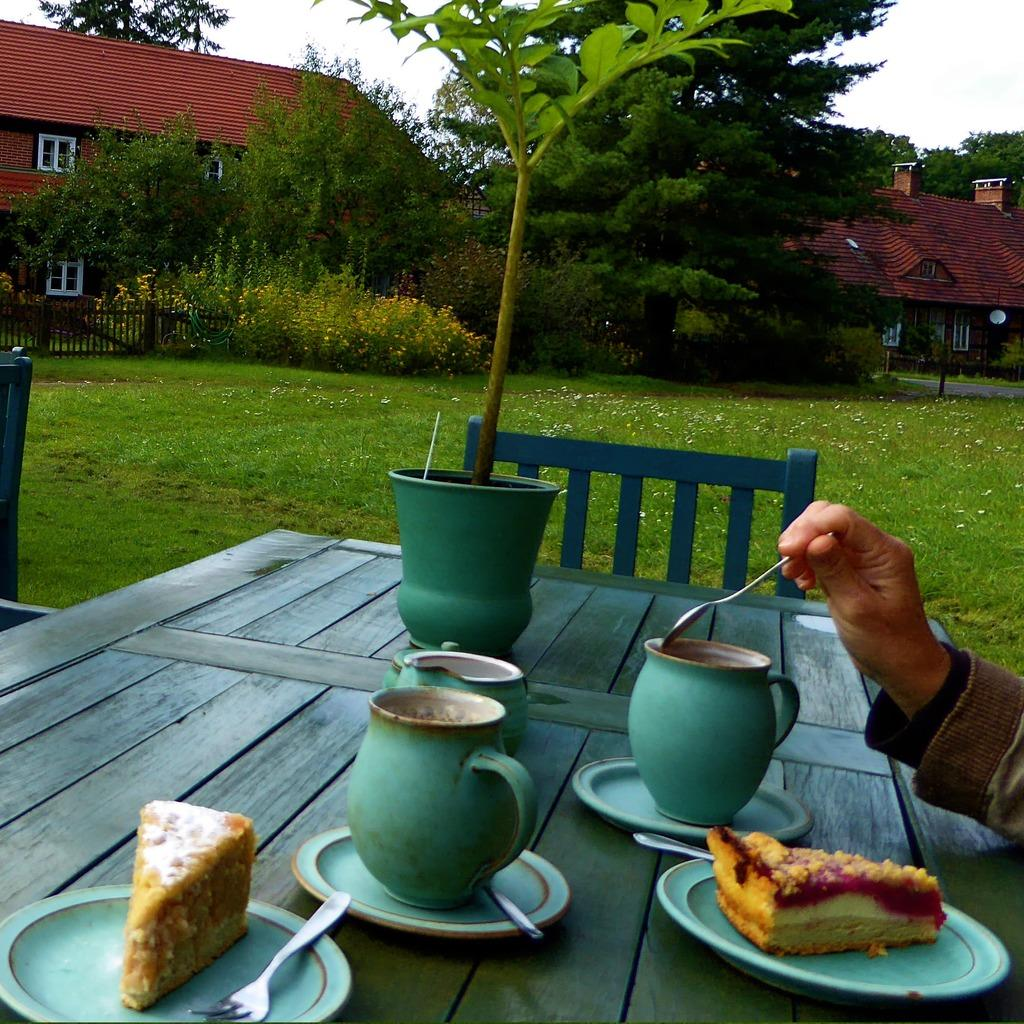What type of vegetation can be seen in the image? There are trees in the image. What structure is visible behind the trees? There is a building visible behind the trees. What part of the natural environment is visible in the image? The sky is visible in the image. How many friends are shown reading books in the image? There are no friends or books present in the image; it features trees and a building. What emotion is displayed by the trees in the image? Trees do not display emotions, so it is not possible to determine the emotion present in the image. 